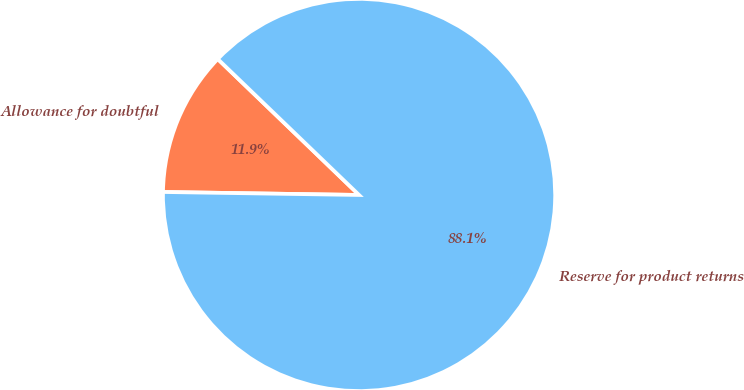Convert chart to OTSL. <chart><loc_0><loc_0><loc_500><loc_500><pie_chart><fcel>Allowance for doubtful<fcel>Reserve for product returns<nl><fcel>11.95%<fcel>88.05%<nl></chart> 